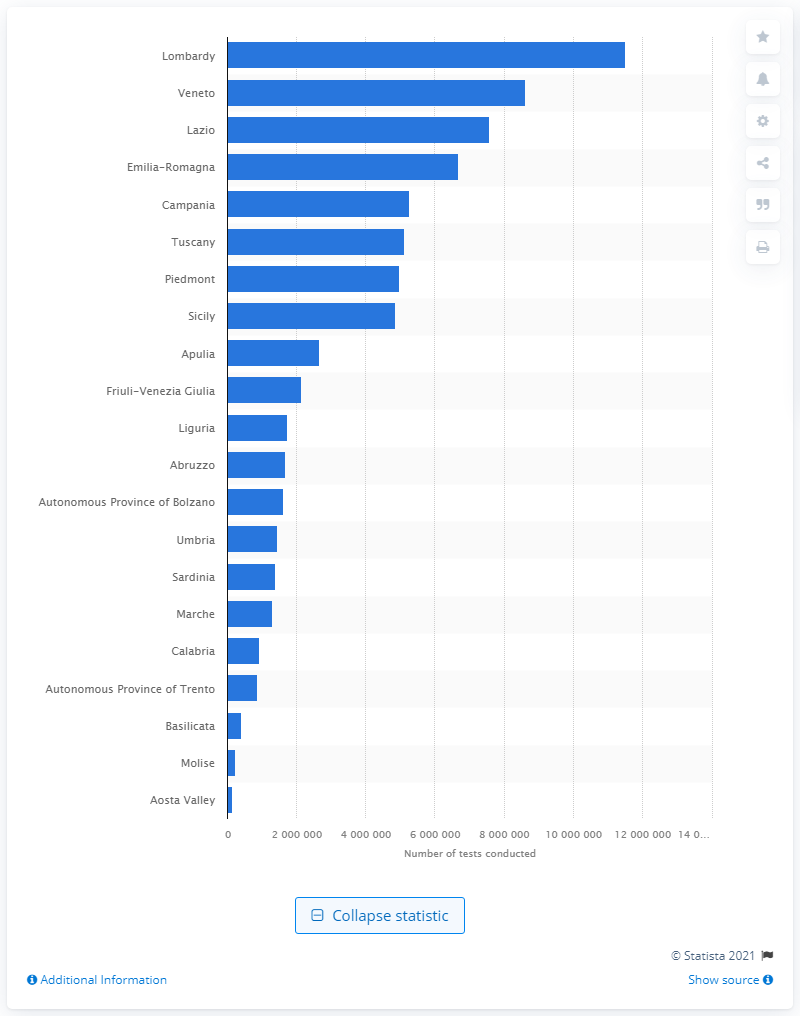Give some essential details in this illustration. Lombardy, a region in Italy, conducted the most tests for COVID-19 infections. 